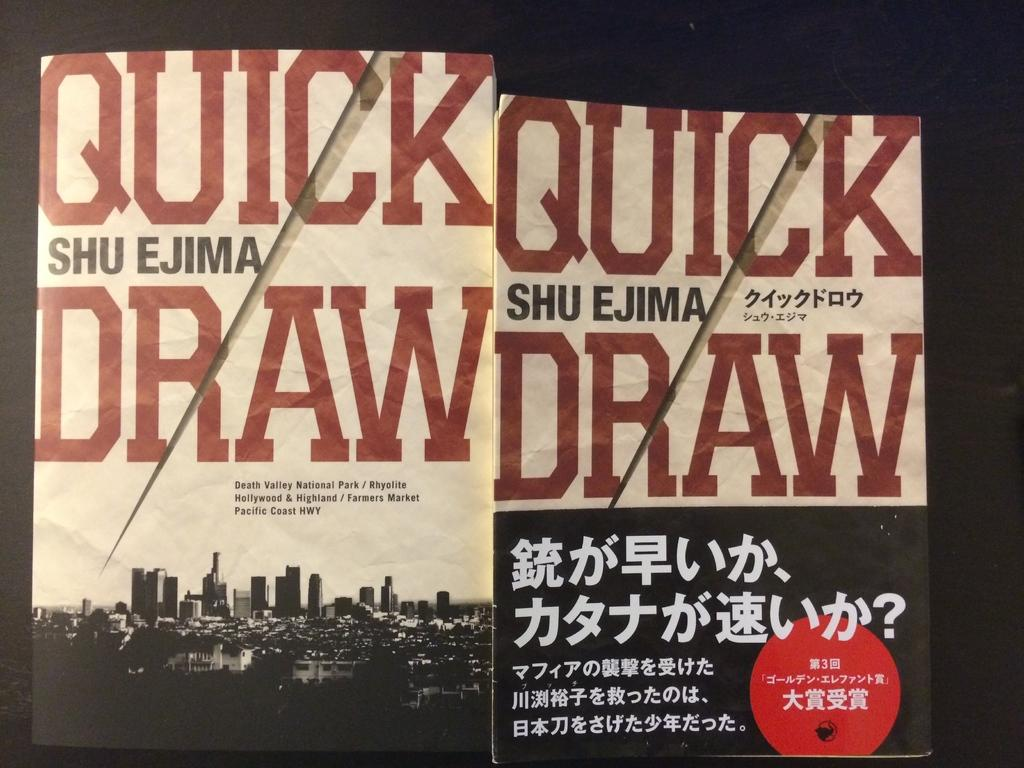<image>
Describe the image concisely. two books titled Quick Draw are shown in English and Japanese 